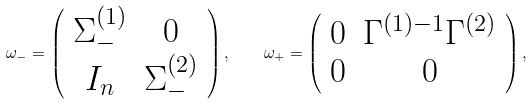<formula> <loc_0><loc_0><loc_500><loc_500>\omega _ { - } = \left ( \begin{array} { c c } { { \Sigma _ { - } ^ { ( 1 ) } } } & { 0 } \\ { { I _ { n } } } & { { \Sigma _ { - } ^ { ( 2 ) } } } \end{array} \right ) , \quad \omega _ { + } = \left ( \begin{array} { c c } { 0 } & { { \Gamma ^ { ( 1 ) - 1 } \Gamma ^ { ( 2 ) } } } \\ { 0 } & { 0 } \end{array} \right ) ,</formula> 